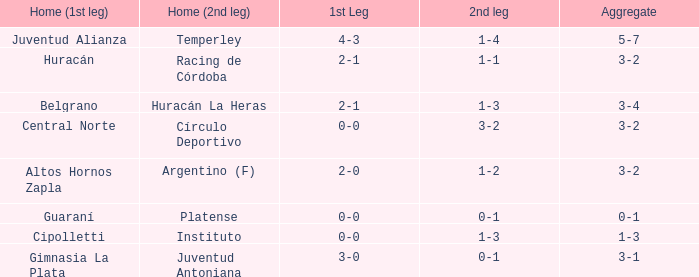Who played at home for the 2nd leg with a score of 1-2? Argentino (F). 